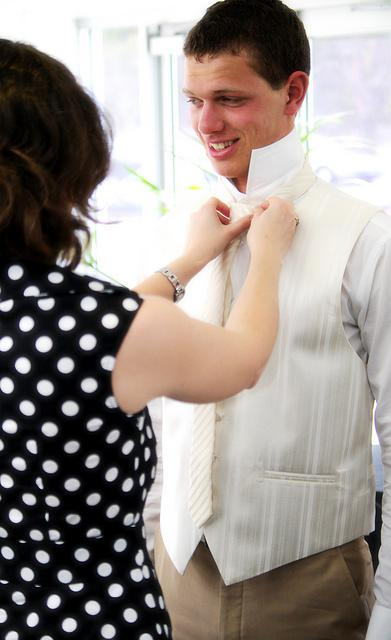What is the woman helping to do?

Choices:
A) burn
B) tie
C) cut
D) feed tie 